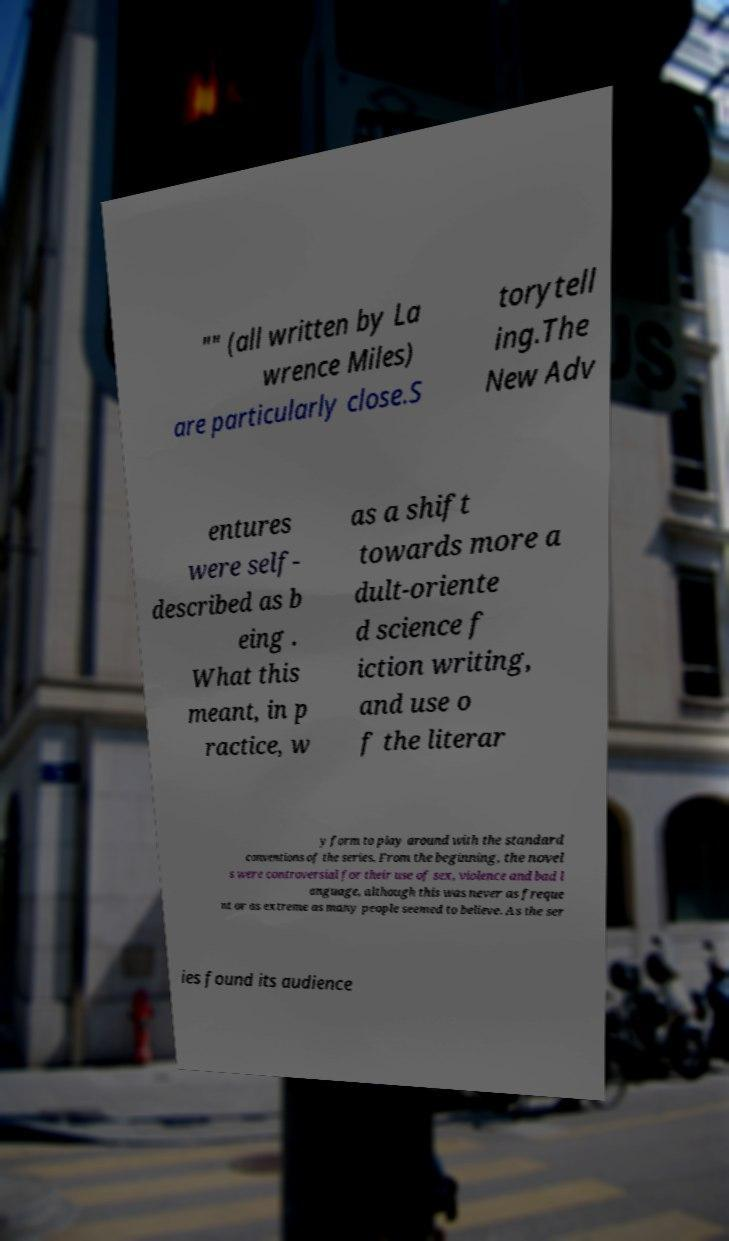What messages or text are displayed in this image? I need them in a readable, typed format. "" (all written by La wrence Miles) are particularly close.S torytell ing.The New Adv entures were self- described as b eing . What this meant, in p ractice, w as a shift towards more a dult-oriente d science f iction writing, and use o f the literar y form to play around with the standard conventions of the series. From the beginning, the novel s were controversial for their use of sex, violence and bad l anguage, although this was never as freque nt or as extreme as many people seemed to believe. As the ser ies found its audience 